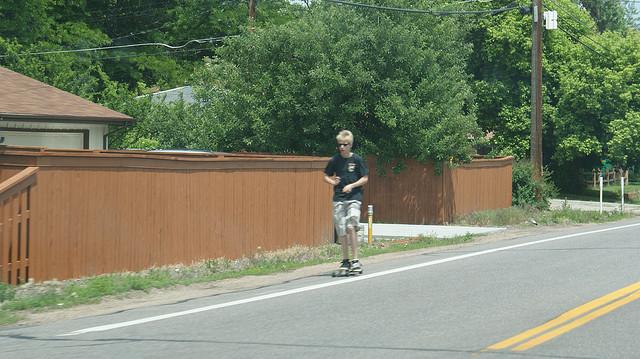What are the yellow stripes in the road for?
Answer briefly. Separate lanes. What is the boy riding?
Short answer required. Skateboard. Is he wearing appropriate shoes for skateboarding?
Keep it brief. Yes. 